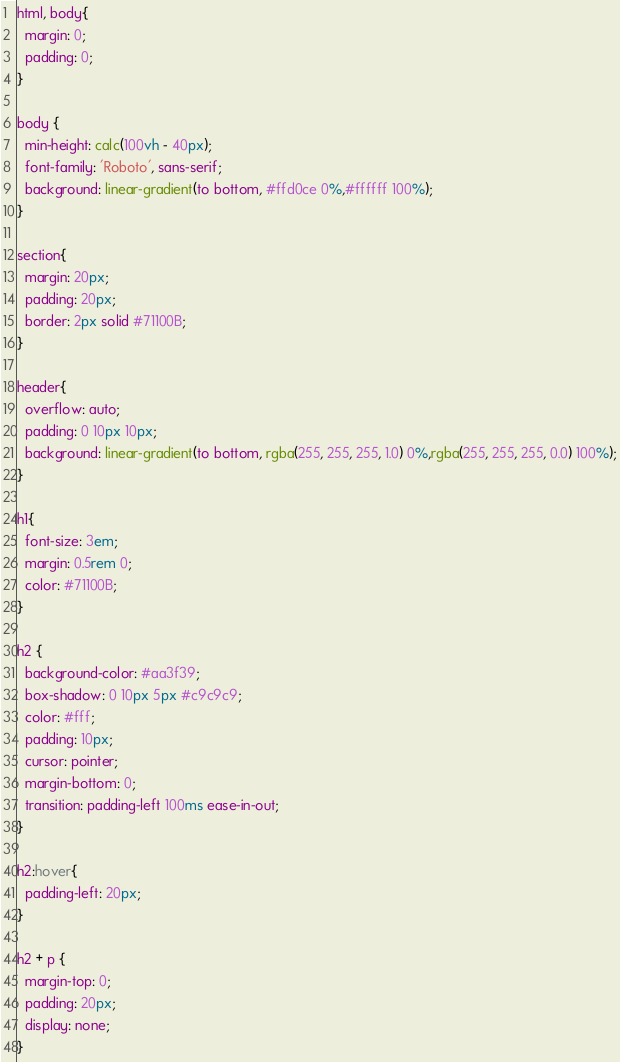<code> <loc_0><loc_0><loc_500><loc_500><_CSS_>html, body{
  margin: 0;
  padding: 0;
}

body {
  min-height: calc(100vh - 40px);
  font-family: 'Roboto', sans-serif;
  background: linear-gradient(to bottom, #ffd0ce 0%,#ffffff 100%);
}

section{
  margin: 20px;
  padding: 20px;
  border: 2px solid #71100B;
}

header{
  overflow: auto;
  padding: 0 10px 10px;
  background: linear-gradient(to bottom, rgba(255, 255, 255, 1.0) 0%,rgba(255, 255, 255, 0.0) 100%);
}

h1{
  font-size: 3em;
  margin: 0.5rem 0;
  color: #71100B;
}

h2 {
  background-color: #aa3f39;
  box-shadow: 0 10px 5px #c9c9c9;
  color: #fff;
  padding: 10px;
  cursor: pointer;
  margin-bottom: 0;
  transition: padding-left 100ms ease-in-out;
}

h2:hover{
  padding-left: 20px;
}

h2 + p {
  margin-top: 0;
  padding: 20px;
  display: none;
}
</code> 